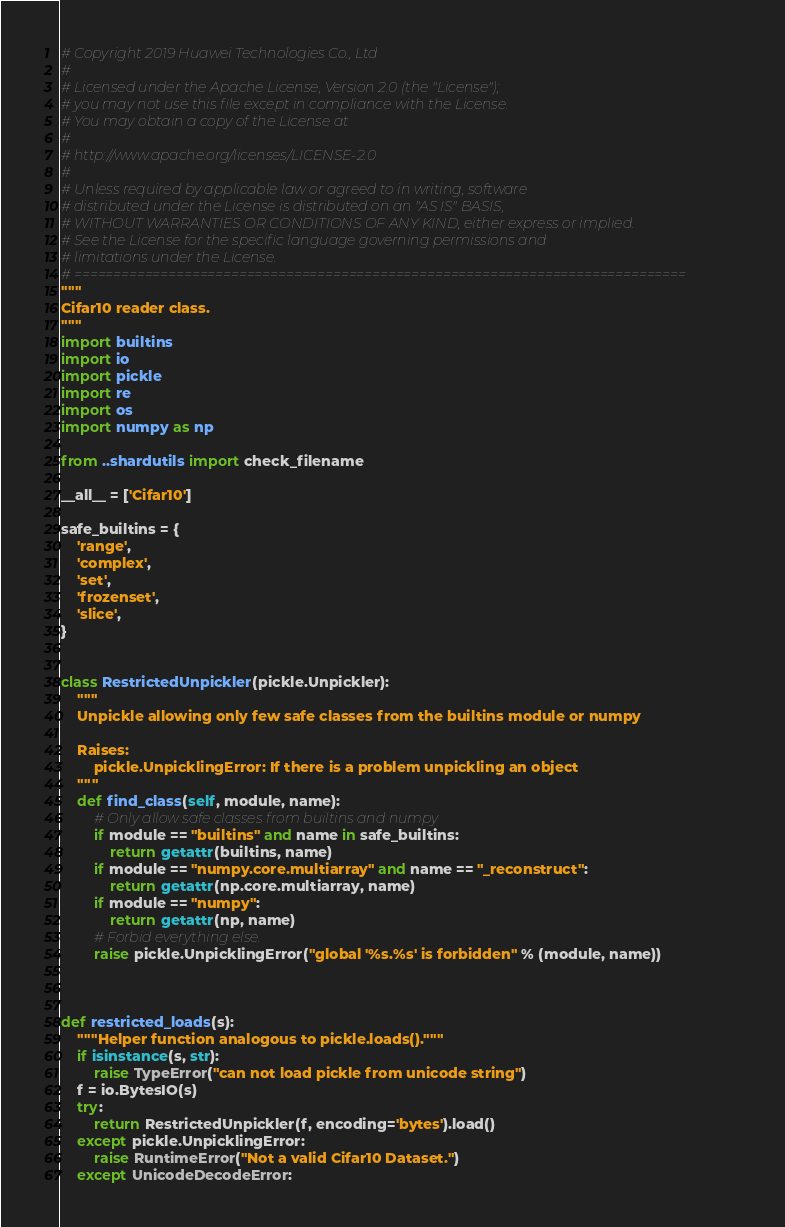<code> <loc_0><loc_0><loc_500><loc_500><_Python_># Copyright 2019 Huawei Technologies Co., Ltd
#
# Licensed under the Apache License, Version 2.0 (the "License");
# you may not use this file except in compliance with the License.
# You may obtain a copy of the License at
#
# http://www.apache.org/licenses/LICENSE-2.0
#
# Unless required by applicable law or agreed to in writing, software
# distributed under the License is distributed on an "AS IS" BASIS,
# WITHOUT WARRANTIES OR CONDITIONS OF ANY KIND, either express or implied.
# See the License for the specific language governing permissions and
# limitations under the License.
# ==============================================================================
"""
Cifar10 reader class.
"""
import builtins
import io
import pickle
import re
import os
import numpy as np

from ..shardutils import check_filename

__all__ = ['Cifar10']

safe_builtins = {
    'range',
    'complex',
    'set',
    'frozenset',
    'slice',
}


class RestrictedUnpickler(pickle.Unpickler):
    """
    Unpickle allowing only few safe classes from the builtins module or numpy

    Raises:
        pickle.UnpicklingError: If there is a problem unpickling an object
    """
    def find_class(self, module, name):
        # Only allow safe classes from builtins and numpy
        if module == "builtins" and name in safe_builtins:
            return getattr(builtins, name)
        if module == "numpy.core.multiarray" and name == "_reconstruct":
            return getattr(np.core.multiarray, name)
        if module == "numpy":
            return getattr(np, name)
        # Forbid everything else.
        raise pickle.UnpicklingError("global '%s.%s' is forbidden" % (module, name))



def restricted_loads(s):
    """Helper function analogous to pickle.loads()."""
    if isinstance(s, str):
        raise TypeError("can not load pickle from unicode string")
    f = io.BytesIO(s)
    try:
        return RestrictedUnpickler(f, encoding='bytes').load()
    except pickle.UnpicklingError:
        raise RuntimeError("Not a valid Cifar10 Dataset.")
    except UnicodeDecodeError:</code> 